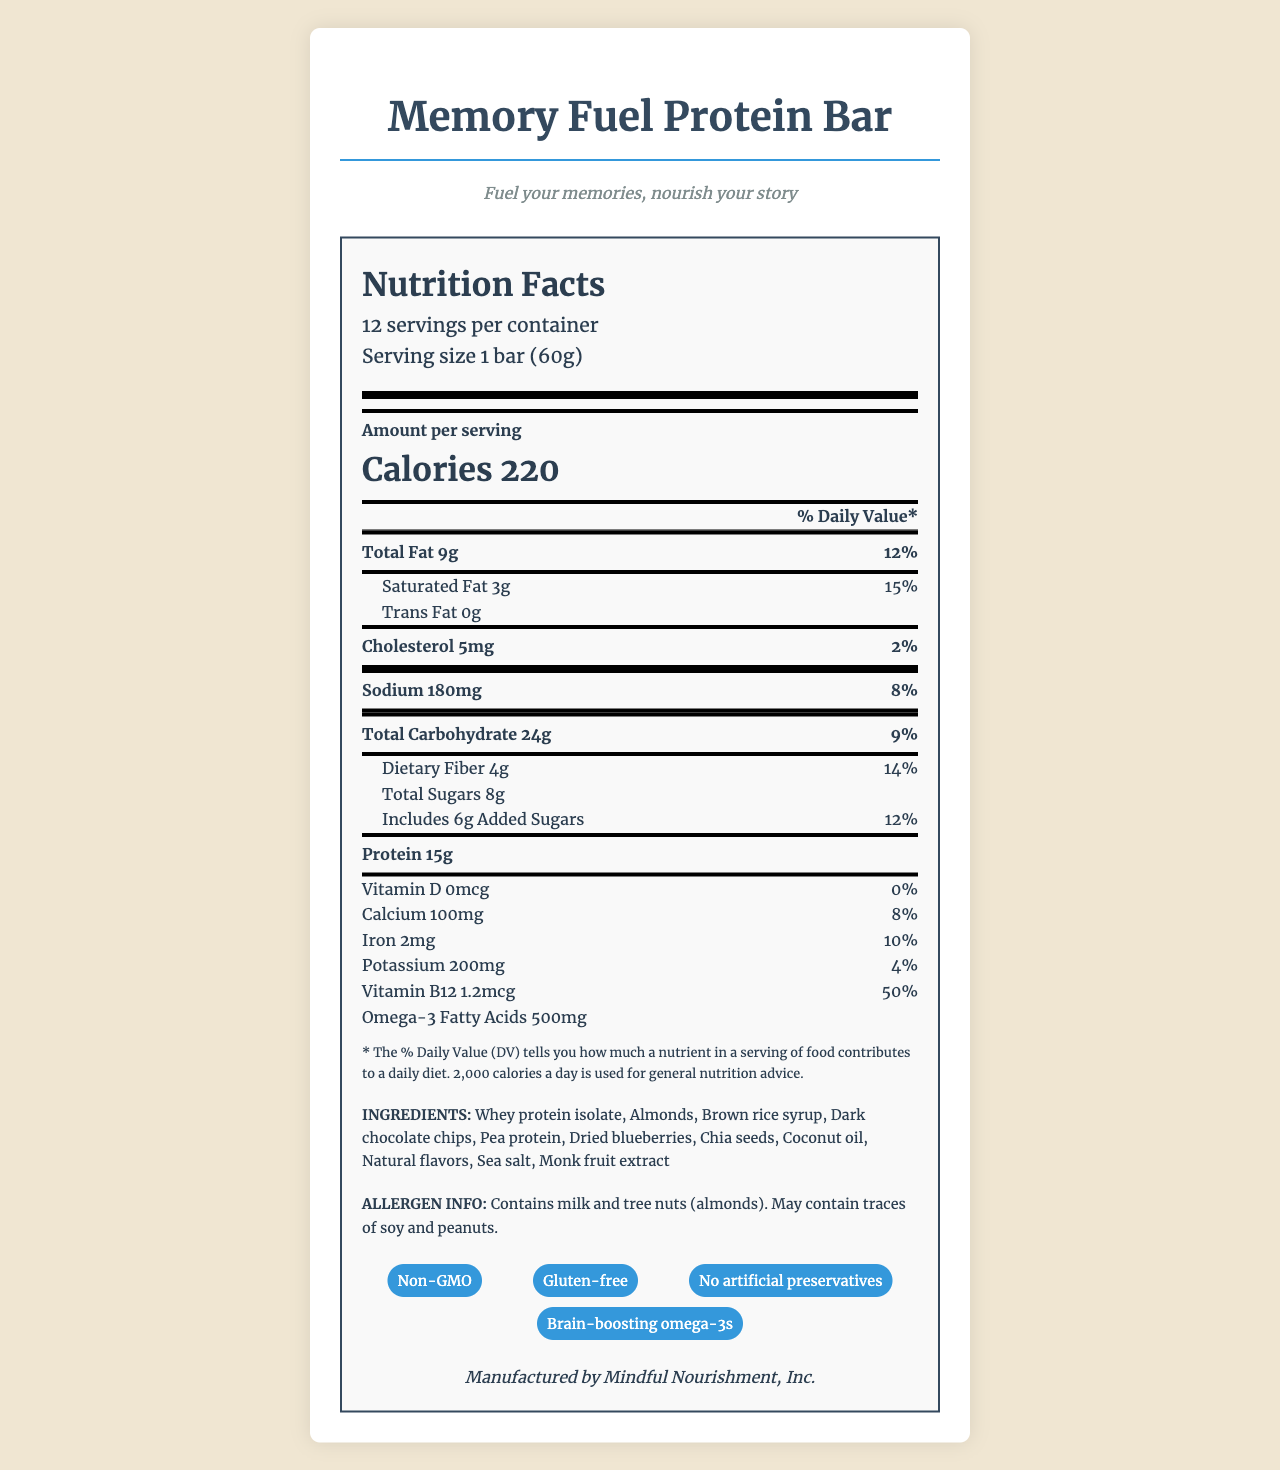What is the serving size of the Memory Fuel Protein Bar? The serving size is stated near the top of the Nutrition Facts section.
Answer: 1 bar (60g) How many servings are there per container? The number of servings per container is listed near the top of the Nutrition Facts section.
Answer: 12 How many calories are in one serving of the Memory Fuel Protein Bar? The calorie content per serving is prominently displayed in the Amount per serving section.
Answer: 220 calories What is the protein content per serving? The protein content is listed under the main nutrients section of the Nutrition Facts label.
Answer: 15g What percentage of the daily value for Vitamin B12 does one serving provide? The daily value percentage for Vitamin B12 is listed in the latter part of the Nutrition Facts label.
Answer: 50% What are the special features of the Memory Fuel Protein Bar? The special features are listed towards the bottom of the document.
Answer: Non-GMO, Gluten-free, No artificial preservatives, Brain-boosting omega-3s What is the total fat content in one serving, and what percentage of the daily value does it correspond to? The total fat content and its daily value percentage are listed in the main nutrients section of the Nutrition Facts label.
Answer: 9g, 12% Which of the following ingredients are not present in the Memory Fuel Protein Bar? A. Whey protein isolate B. Soy lecithin C. Dried blueberries D. Monk fruit extract The list of ingredients does not include soy lecithin, whereas the other options are mentioned.
Answer: B. Soy lecithin How much sodium is in one serving, and what is its daily value percentage? The sodium content and its daily value percentage are listed in the main nutrients section of the Nutrition Facts label.
Answer: 180mg, 8% Which ingredient in the bar provides a source of omega-3 fatty acids? A. Almonds B. Dark chocolate chips C. Chia seeds D. Coconut oil Chia seeds are known to be a source of omega-3 fatty acids.
Answer: C. Chia seeds Is the Memory Fuel Protein Bar gluten-free? The special features list includes gluten-free as one of the attributes.
Answer: Yes Summarize the main features of the Memory Fuel Protein Bar's Nutrition Facts label. This summary captures key nutritional data, special attributes, and allergen information as presented on the label.
Answer: The Memory Fuel Protein Bar provides 220 calories per 60g serving, with significant contributions of protein (15g) and essential nutrients like Vitamin B12 (50% DV). It has 9g of total fat (12% DV), 180mg of sodium (8% DV), and 24g of total carbohydrates (9% DV), including 4g dietary fiber (14% DV) and 6g added sugars (12% DV). Special features include being non-GMO, gluten-free, having no artificial preservatives, and containing brain-boosting omega-3s. Contains allergens like milk and tree nuts and may contain soy and peanuts. Who manufactures the Memory Fuel Protein Bar? The manufacturer information is noted at the bottom of the document.
Answer: Mindful Nourishment, Inc. Does the Memory Fuel Protein Bar contain any artificial preservatives? The special features section explicitly states that there are no artificial preservatives in the bar.
Answer: No Is the total carbohydrate content higher than the protein content in one serving? The total carbohydrate content is 24g, which is higher than the protein content of 15g.
Answer: Yes Can we determine if the Memory Fuel Protein Bar is suitable for vegans based on the label? The label mentions the presence of whey protein isolate and milk, which suggests it is not vegan, but it does not explicitly state whether it's suitable for vegans.
Answer: Not enough information 